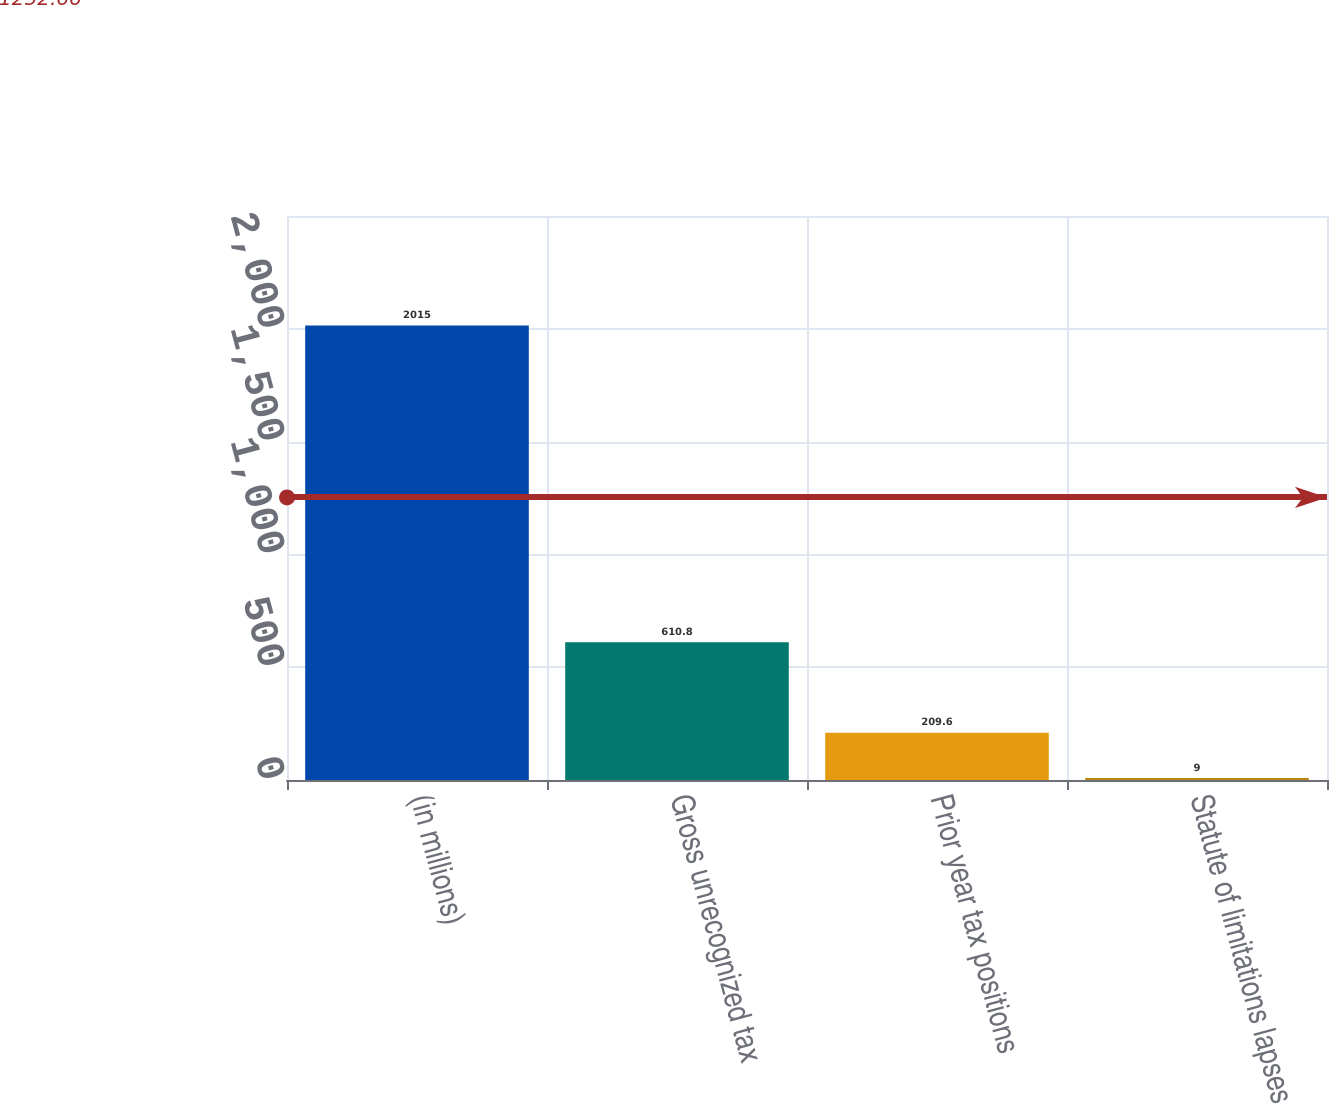<chart> <loc_0><loc_0><loc_500><loc_500><bar_chart><fcel>(in millions)<fcel>Gross unrecognized tax<fcel>Prior year tax positions<fcel>Statute of limitations lapses<nl><fcel>2015<fcel>610.8<fcel>209.6<fcel>9<nl></chart> 